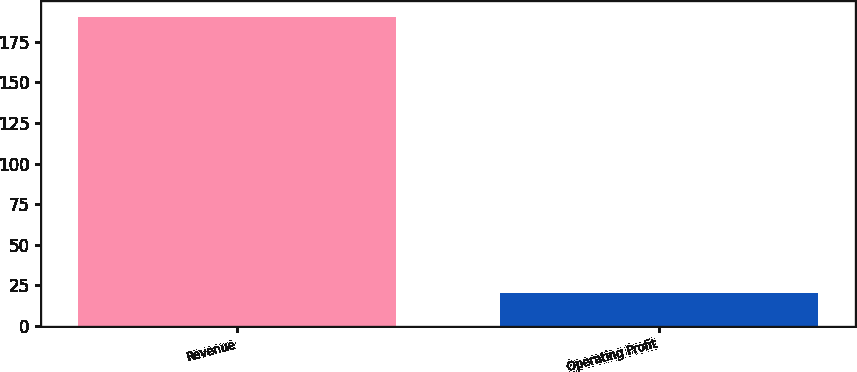Convert chart. <chart><loc_0><loc_0><loc_500><loc_500><bar_chart><fcel>Revenue<fcel>Operating Profit<nl><fcel>190.2<fcel>20.5<nl></chart> 